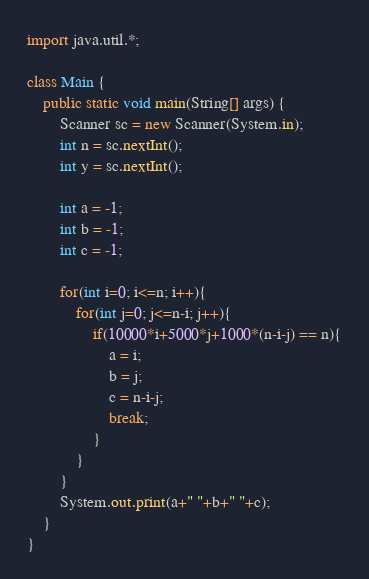<code> <loc_0><loc_0><loc_500><loc_500><_Java_>import java.util.*;
 
class Main {
    public static void main(String[] args) {
        Scanner sc = new Scanner(System.in);
        int n = sc.nextInt();
        int y = sc.nextInt();

        int a = -1;
        int b = -1;
        int c = -1;

        for(int i=0; i<=n; i++){
        	for(int j=0; j<=n-i; j++){
                if(10000*i+5000*j+1000*(n-i-j) == n){
                    a = i;
                    b = j;
                    c = n-i-j;
                    break;
                }
            }
        }
        System.out.print(a+" "+b+" "+c);
    }
}
</code> 